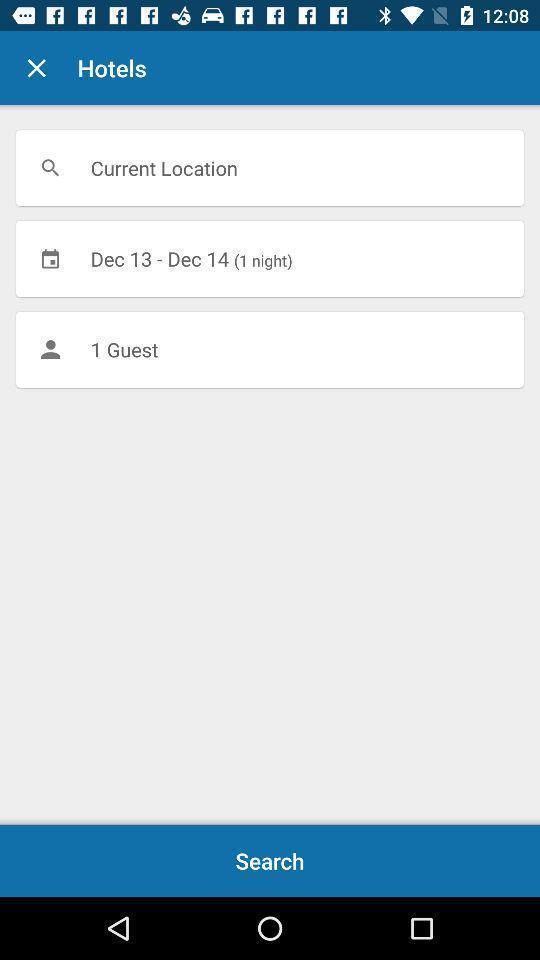What is the overall content of this screenshot? Search option to find hotels for booking. 